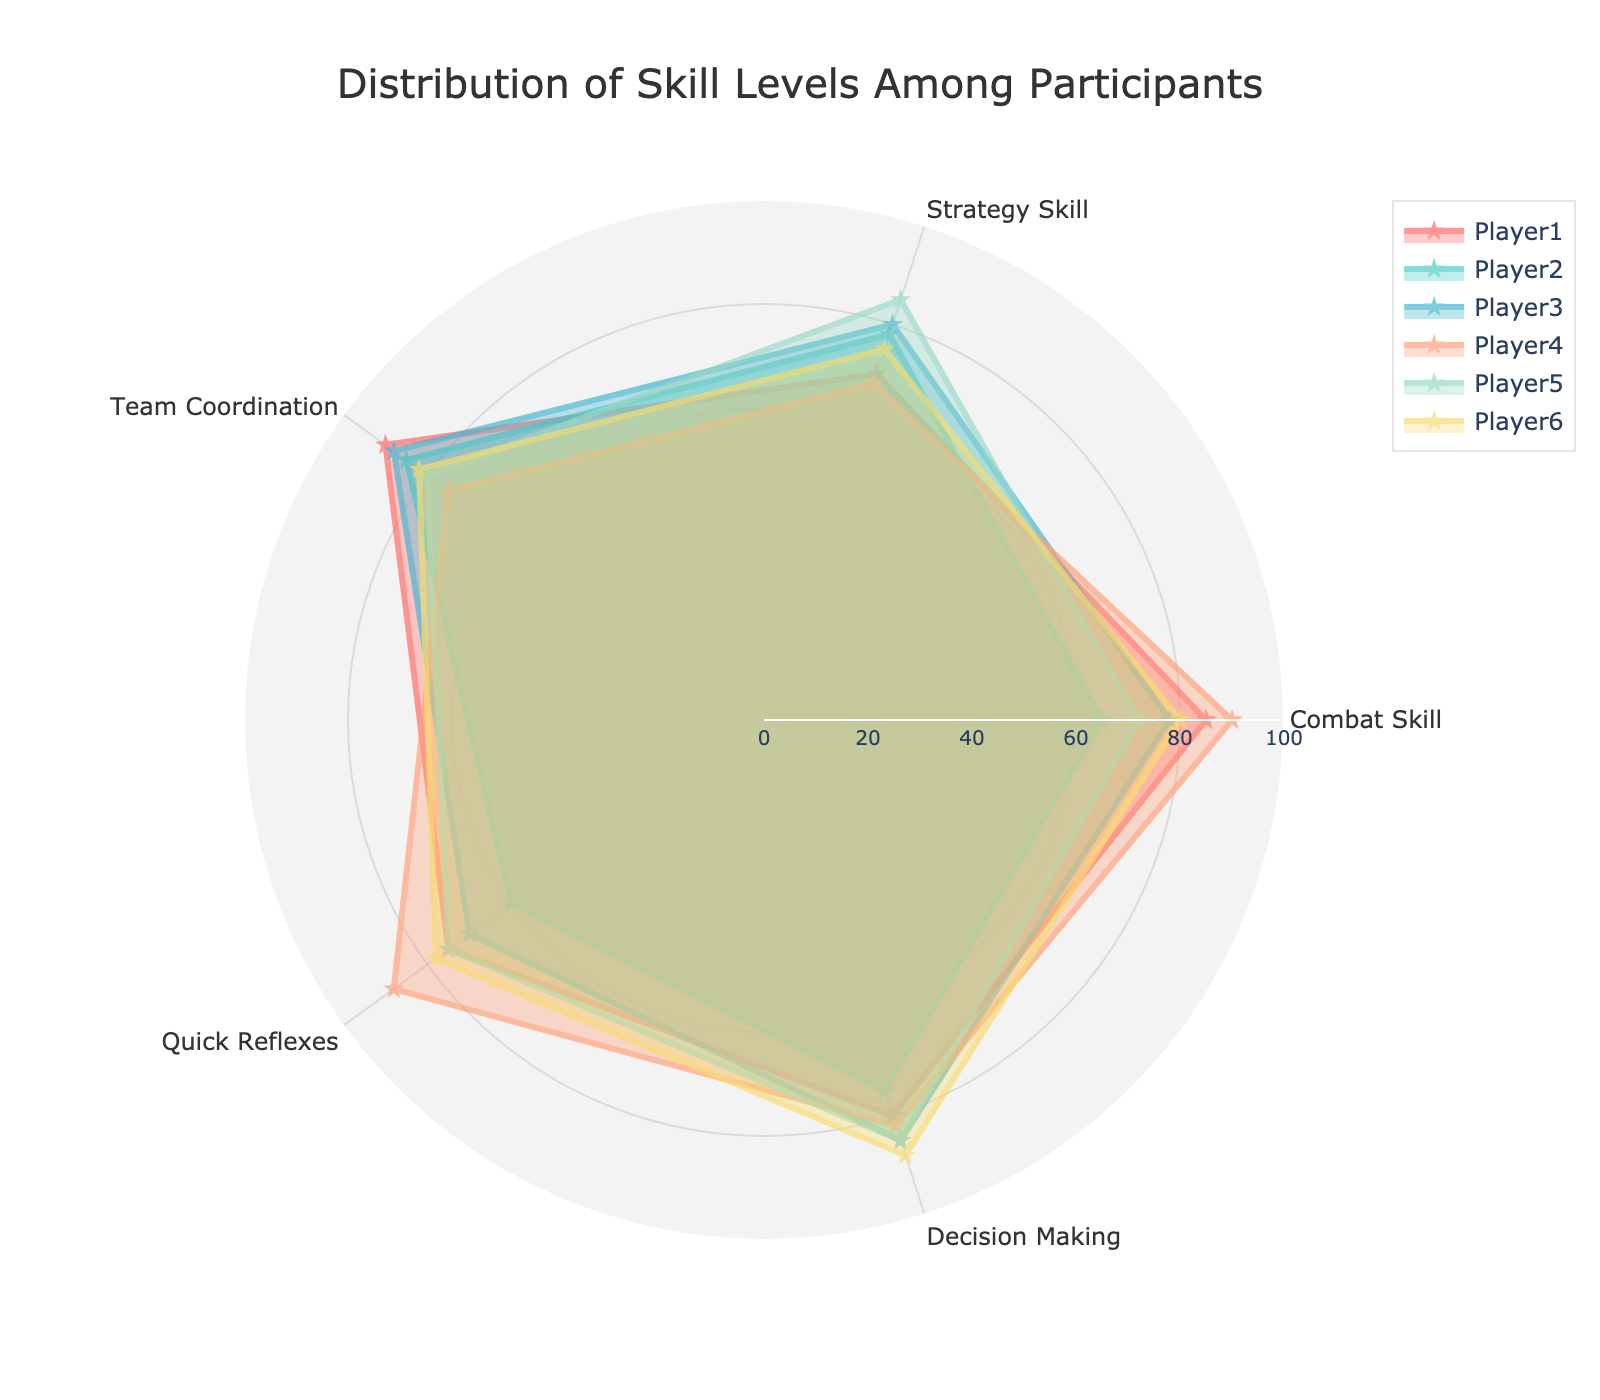How many players are represented in the radar chart? The radar chart has one line per player, and each player is distinctly labeled. By counting the number of unique lines or names, we can determine the number of players.
Answer: 6 Which player has the highest combat skill? By examining the Combat Skill dimension for all the players and comparing their values, we can identify the player with the highest value. Player4 has a combat skill of 90, which is the highest.
Answer: Player4 What is the average strategy skill across all players? Add the strategy skill values for each player (70 + 78 + 80 + 68 + 85 + 75), then divide by the number of players (6). The sum is 456, and the average is 456/6.
Answer: 76 Among the attributes, which one does Player3 excel in the most? For Player3, compare the values in the different attributes: Combat Skill (78), Strategy Skill (80), Team Coordination (88), Quick Reflexes (70), and Decision Making (85). The highest value is 88 in Team Coordination.
Answer: Team Coordination Which two players have the closest levels in quick reflexes? Compare the Quick Reflexes values for all players: Player1 (75), Player2 (60), Player3 (70), Player4 (88), Player5 (75), Player6 (78). Player1 and Player5 both have a quick reflex level of 75.
Answer: Player1 and Player5 Excluding Player4, what is the average decision-making skill? Exclude Player4's decision-making skill (82), then add the remaining values (80 + 75 + 85 + 85 + 88) and divide by the number of remaining players (5). The sum is 413, and the average is 413/5.
Answer: 82.6 Which player has the most balanced skill distribution across all attributes? Look for the player whose skill values are most consistent across all attributes. By visually inspecting the radar chart, note that Player6's values (80, 75, 82, 78, 88) are quite evenly distributed and close to each other.
Answer: Player6 Between Player2 and Player5, who has higher team coordination? Compare the Team Coordination values for Player2 (85) and Player5 (80). Player2 has a higher value.
Answer: Player2 What is the title of the radar chart? The title is typically displayed at the top of the chart. Here, it reads "Distribution of Skill Levels Among Participants".
Answer: Distribution of Skill Levels Among Participants 